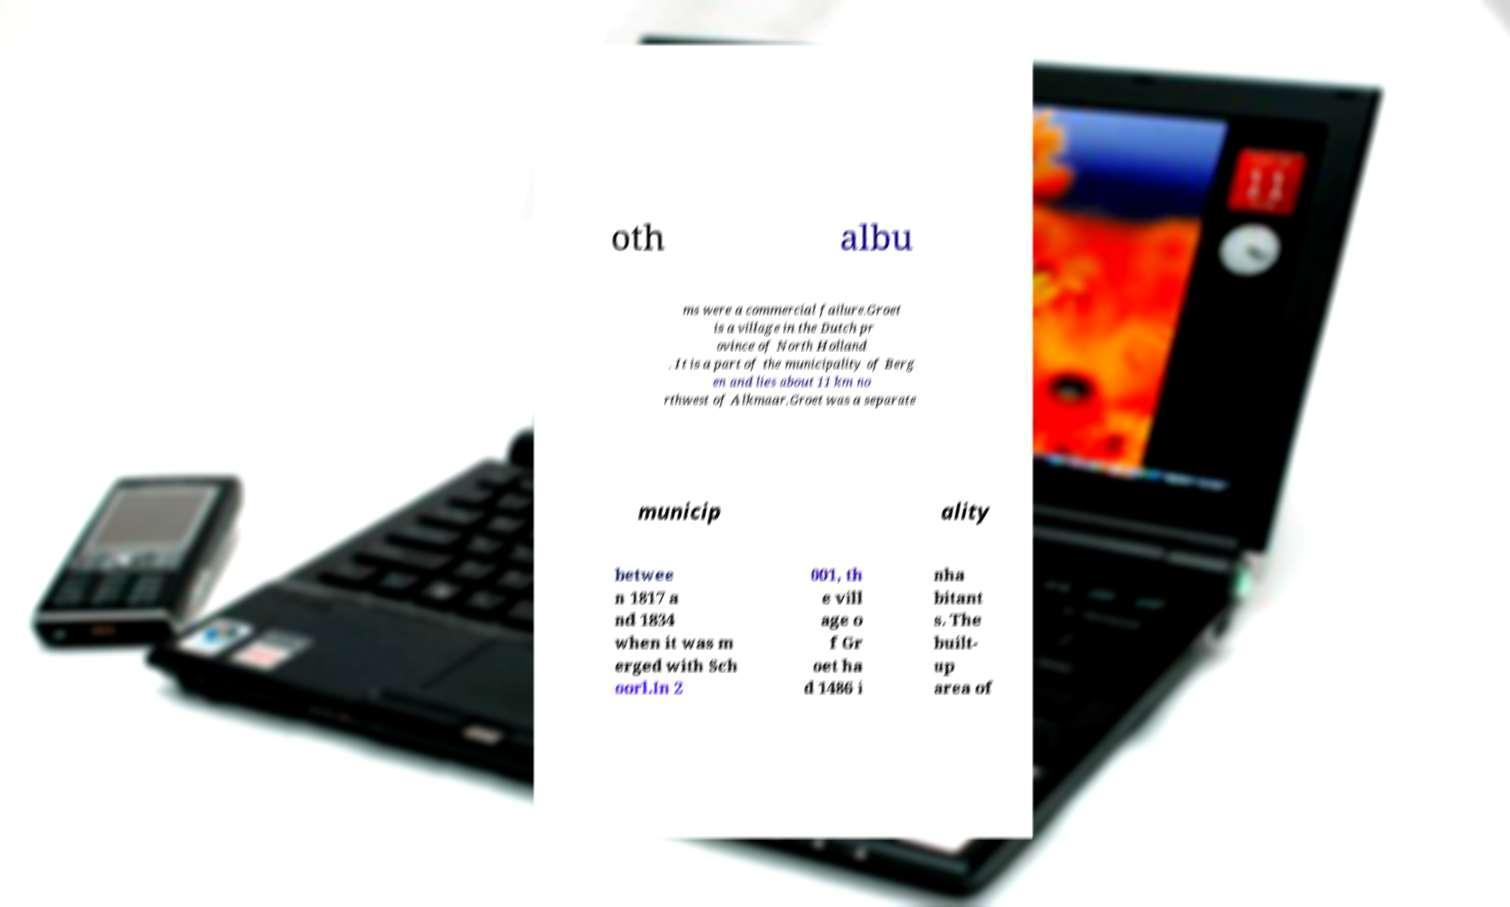For documentation purposes, I need the text within this image transcribed. Could you provide that? oth albu ms were a commercial failure.Groet is a village in the Dutch pr ovince of North Holland . It is a part of the municipality of Berg en and lies about 11 km no rthwest of Alkmaar.Groet was a separate municip ality betwee n 1817 a nd 1834 when it was m erged with Sch oorl.In 2 001, th e vill age o f Gr oet ha d 1486 i nha bitant s. The built- up area of 